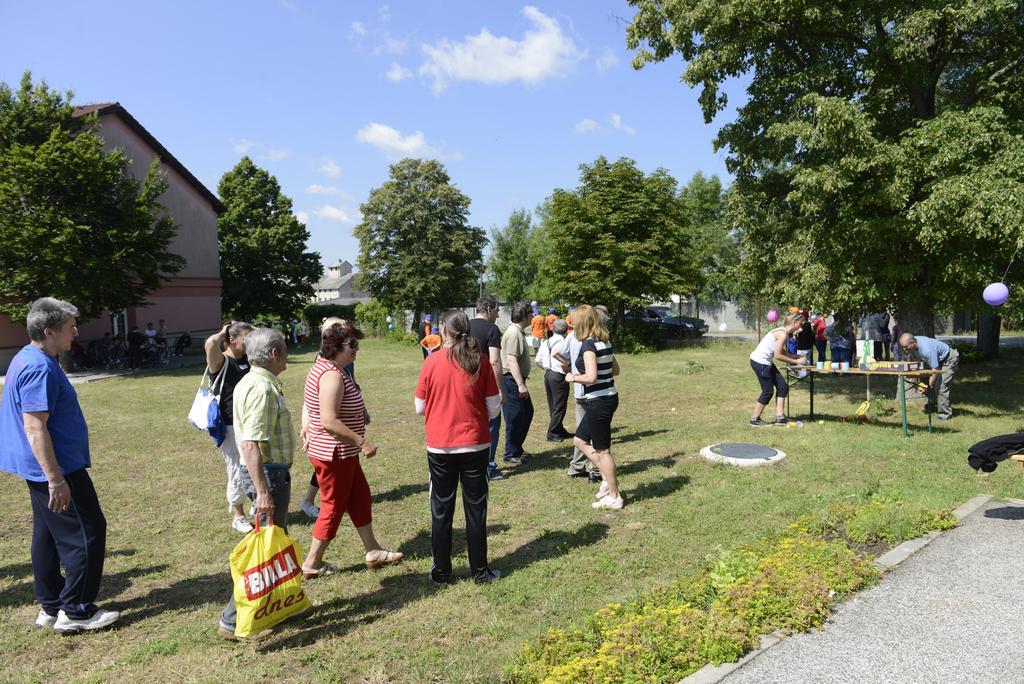How would you summarize this image in a sentence or two? In this picture I can see a group of people in the middle, on the right side there is a table. In the background there are trees and houses, there is a car on the road. At the top I can see the sky. 